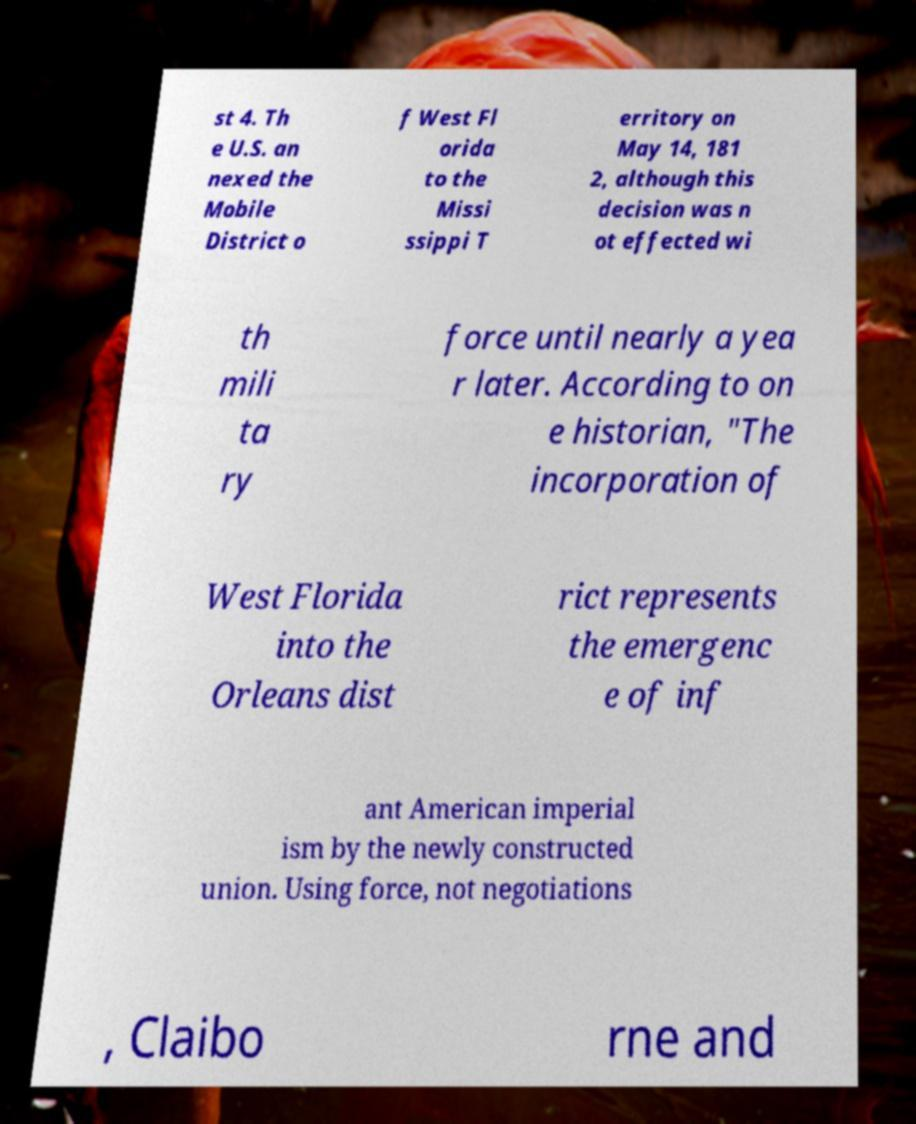What messages or text are displayed in this image? I need them in a readable, typed format. st 4. Th e U.S. an nexed the Mobile District o f West Fl orida to the Missi ssippi T erritory on May 14, 181 2, although this decision was n ot effected wi th mili ta ry force until nearly a yea r later. According to on e historian, "The incorporation of West Florida into the Orleans dist rict represents the emergenc e of inf ant American imperial ism by the newly constructed union. Using force, not negotiations , Claibo rne and 